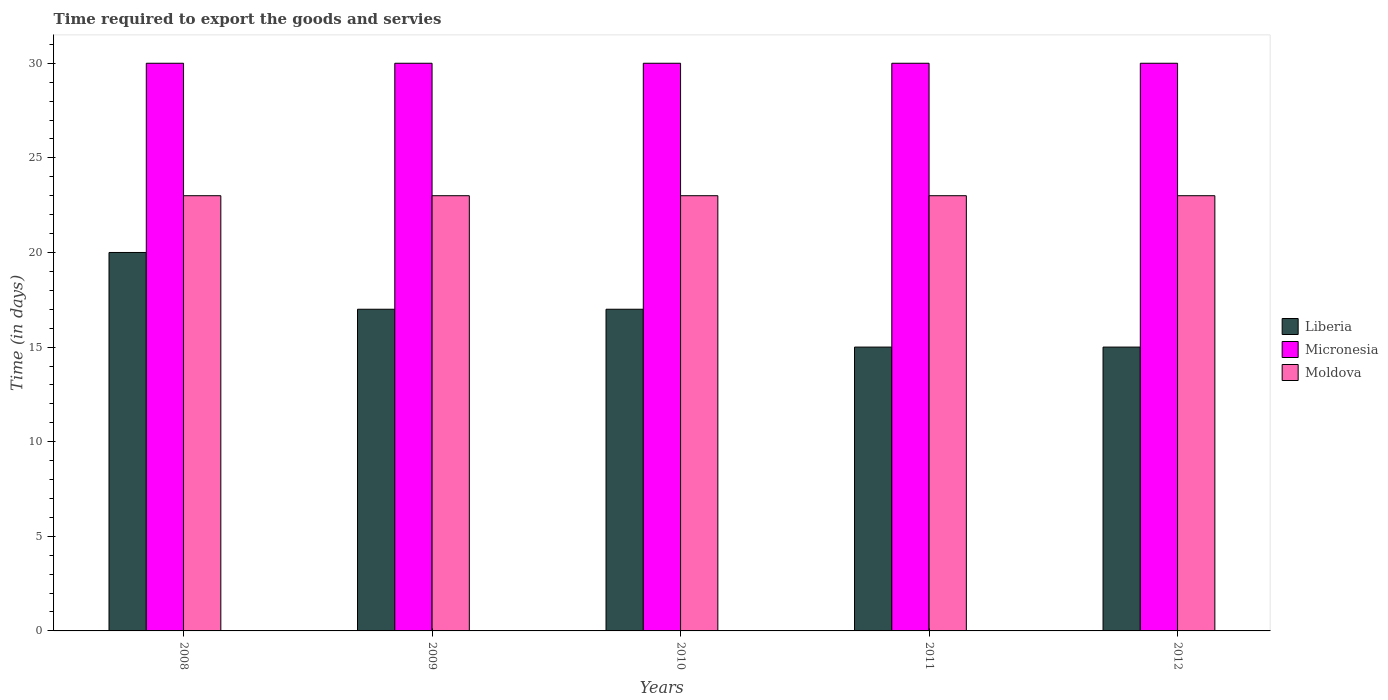How many different coloured bars are there?
Give a very brief answer. 3. Are the number of bars per tick equal to the number of legend labels?
Provide a succinct answer. Yes. Are the number of bars on each tick of the X-axis equal?
Offer a terse response. Yes. In how many cases, is the number of bars for a given year not equal to the number of legend labels?
Make the answer very short. 0. What is the number of days required to export the goods and services in Moldova in 2010?
Ensure brevity in your answer.  23. Across all years, what is the maximum number of days required to export the goods and services in Liberia?
Make the answer very short. 20. Across all years, what is the minimum number of days required to export the goods and services in Moldova?
Make the answer very short. 23. In which year was the number of days required to export the goods and services in Liberia minimum?
Ensure brevity in your answer.  2011. What is the total number of days required to export the goods and services in Moldova in the graph?
Give a very brief answer. 115. What is the difference between the number of days required to export the goods and services in Moldova in 2010 and the number of days required to export the goods and services in Micronesia in 2009?
Keep it short and to the point. -7. In the year 2011, what is the difference between the number of days required to export the goods and services in Micronesia and number of days required to export the goods and services in Moldova?
Make the answer very short. 7. What is the ratio of the number of days required to export the goods and services in Moldova in 2008 to that in 2010?
Provide a succinct answer. 1. What is the difference between the highest and the second highest number of days required to export the goods and services in Moldova?
Ensure brevity in your answer.  0. What is the difference between the highest and the lowest number of days required to export the goods and services in Micronesia?
Provide a short and direct response. 0. What does the 3rd bar from the left in 2008 represents?
Your answer should be compact. Moldova. What does the 1st bar from the right in 2011 represents?
Keep it short and to the point. Moldova. How many years are there in the graph?
Make the answer very short. 5. What is the difference between two consecutive major ticks on the Y-axis?
Offer a terse response. 5. Are the values on the major ticks of Y-axis written in scientific E-notation?
Your response must be concise. No. Does the graph contain grids?
Make the answer very short. No. Where does the legend appear in the graph?
Your answer should be very brief. Center right. How many legend labels are there?
Keep it short and to the point. 3. How are the legend labels stacked?
Provide a short and direct response. Vertical. What is the title of the graph?
Offer a very short reply. Time required to export the goods and servies. Does "Sri Lanka" appear as one of the legend labels in the graph?
Offer a terse response. No. What is the label or title of the Y-axis?
Your answer should be compact. Time (in days). What is the Time (in days) in Moldova in 2008?
Provide a succinct answer. 23. What is the Time (in days) in Liberia in 2009?
Offer a terse response. 17. What is the Time (in days) of Micronesia in 2009?
Offer a very short reply. 30. What is the Time (in days) in Liberia in 2010?
Your answer should be compact. 17. What is the Time (in days) of Moldova in 2010?
Keep it short and to the point. 23. What is the Time (in days) in Liberia in 2011?
Keep it short and to the point. 15. What is the Time (in days) in Moldova in 2011?
Offer a very short reply. 23. What is the Time (in days) in Liberia in 2012?
Give a very brief answer. 15. What is the Time (in days) in Moldova in 2012?
Provide a short and direct response. 23. Across all years, what is the maximum Time (in days) in Liberia?
Make the answer very short. 20. Across all years, what is the maximum Time (in days) of Moldova?
Offer a very short reply. 23. Across all years, what is the minimum Time (in days) in Liberia?
Your answer should be compact. 15. Across all years, what is the minimum Time (in days) of Moldova?
Give a very brief answer. 23. What is the total Time (in days) in Micronesia in the graph?
Your response must be concise. 150. What is the total Time (in days) of Moldova in the graph?
Make the answer very short. 115. What is the difference between the Time (in days) of Liberia in 2008 and that in 2009?
Ensure brevity in your answer.  3. What is the difference between the Time (in days) in Moldova in 2008 and that in 2009?
Ensure brevity in your answer.  0. What is the difference between the Time (in days) of Liberia in 2008 and that in 2010?
Your response must be concise. 3. What is the difference between the Time (in days) of Moldova in 2008 and that in 2010?
Your answer should be compact. 0. What is the difference between the Time (in days) in Micronesia in 2008 and that in 2011?
Provide a succinct answer. 0. What is the difference between the Time (in days) in Liberia in 2008 and that in 2012?
Offer a very short reply. 5. What is the difference between the Time (in days) of Moldova in 2008 and that in 2012?
Provide a succinct answer. 0. What is the difference between the Time (in days) in Liberia in 2009 and that in 2010?
Offer a very short reply. 0. What is the difference between the Time (in days) in Moldova in 2009 and that in 2010?
Provide a succinct answer. 0. What is the difference between the Time (in days) of Liberia in 2009 and that in 2011?
Offer a terse response. 2. What is the difference between the Time (in days) in Micronesia in 2009 and that in 2011?
Offer a very short reply. 0. What is the difference between the Time (in days) of Moldova in 2009 and that in 2011?
Ensure brevity in your answer.  0. What is the difference between the Time (in days) in Liberia in 2009 and that in 2012?
Offer a very short reply. 2. What is the difference between the Time (in days) of Micronesia in 2009 and that in 2012?
Your answer should be compact. 0. What is the difference between the Time (in days) of Moldova in 2009 and that in 2012?
Provide a short and direct response. 0. What is the difference between the Time (in days) in Micronesia in 2010 and that in 2011?
Make the answer very short. 0. What is the difference between the Time (in days) of Moldova in 2010 and that in 2011?
Your answer should be very brief. 0. What is the difference between the Time (in days) in Liberia in 2011 and that in 2012?
Make the answer very short. 0. What is the difference between the Time (in days) of Liberia in 2008 and the Time (in days) of Micronesia in 2010?
Provide a succinct answer. -10. What is the difference between the Time (in days) of Micronesia in 2008 and the Time (in days) of Moldova in 2010?
Ensure brevity in your answer.  7. What is the difference between the Time (in days) of Liberia in 2008 and the Time (in days) of Micronesia in 2011?
Give a very brief answer. -10. What is the difference between the Time (in days) in Liberia in 2008 and the Time (in days) in Moldova in 2011?
Offer a terse response. -3. What is the difference between the Time (in days) in Liberia in 2008 and the Time (in days) in Micronesia in 2012?
Offer a very short reply. -10. What is the difference between the Time (in days) in Liberia in 2008 and the Time (in days) in Moldova in 2012?
Your answer should be compact. -3. What is the difference between the Time (in days) of Liberia in 2009 and the Time (in days) of Micronesia in 2010?
Give a very brief answer. -13. What is the difference between the Time (in days) of Liberia in 2009 and the Time (in days) of Moldova in 2010?
Give a very brief answer. -6. What is the difference between the Time (in days) of Micronesia in 2009 and the Time (in days) of Moldova in 2010?
Your response must be concise. 7. What is the difference between the Time (in days) in Liberia in 2009 and the Time (in days) in Micronesia in 2011?
Your answer should be compact. -13. What is the difference between the Time (in days) of Liberia in 2009 and the Time (in days) of Moldova in 2012?
Provide a short and direct response. -6. What is the difference between the Time (in days) of Liberia in 2010 and the Time (in days) of Moldova in 2011?
Offer a terse response. -6. What is the difference between the Time (in days) of Micronesia in 2010 and the Time (in days) of Moldova in 2011?
Your answer should be compact. 7. What is the difference between the Time (in days) in Liberia in 2010 and the Time (in days) in Moldova in 2012?
Provide a succinct answer. -6. What is the difference between the Time (in days) of Micronesia in 2010 and the Time (in days) of Moldova in 2012?
Your answer should be compact. 7. What is the difference between the Time (in days) of Liberia in 2011 and the Time (in days) of Micronesia in 2012?
Keep it short and to the point. -15. What is the difference between the Time (in days) in Liberia in 2011 and the Time (in days) in Moldova in 2012?
Ensure brevity in your answer.  -8. What is the difference between the Time (in days) in Micronesia in 2011 and the Time (in days) in Moldova in 2012?
Your response must be concise. 7. What is the average Time (in days) of Liberia per year?
Keep it short and to the point. 16.8. What is the average Time (in days) in Micronesia per year?
Give a very brief answer. 30. In the year 2008, what is the difference between the Time (in days) in Liberia and Time (in days) in Micronesia?
Provide a succinct answer. -10. In the year 2008, what is the difference between the Time (in days) of Liberia and Time (in days) of Moldova?
Ensure brevity in your answer.  -3. In the year 2008, what is the difference between the Time (in days) of Micronesia and Time (in days) of Moldova?
Give a very brief answer. 7. In the year 2009, what is the difference between the Time (in days) in Liberia and Time (in days) in Moldova?
Provide a succinct answer. -6. In the year 2010, what is the difference between the Time (in days) in Liberia and Time (in days) in Micronesia?
Make the answer very short. -13. In the year 2010, what is the difference between the Time (in days) of Liberia and Time (in days) of Moldova?
Your answer should be compact. -6. In the year 2010, what is the difference between the Time (in days) in Micronesia and Time (in days) in Moldova?
Your answer should be compact. 7. In the year 2011, what is the difference between the Time (in days) in Liberia and Time (in days) in Moldova?
Keep it short and to the point. -8. In the year 2011, what is the difference between the Time (in days) in Micronesia and Time (in days) in Moldova?
Provide a short and direct response. 7. In the year 2012, what is the difference between the Time (in days) of Liberia and Time (in days) of Micronesia?
Offer a terse response. -15. What is the ratio of the Time (in days) of Liberia in 2008 to that in 2009?
Provide a short and direct response. 1.18. What is the ratio of the Time (in days) of Liberia in 2008 to that in 2010?
Offer a very short reply. 1.18. What is the ratio of the Time (in days) of Micronesia in 2008 to that in 2010?
Your answer should be compact. 1. What is the ratio of the Time (in days) of Moldova in 2008 to that in 2010?
Your answer should be very brief. 1. What is the ratio of the Time (in days) of Liberia in 2008 to that in 2011?
Your response must be concise. 1.33. What is the ratio of the Time (in days) of Liberia in 2008 to that in 2012?
Provide a succinct answer. 1.33. What is the ratio of the Time (in days) of Micronesia in 2008 to that in 2012?
Your answer should be compact. 1. What is the ratio of the Time (in days) in Micronesia in 2009 to that in 2010?
Your answer should be very brief. 1. What is the ratio of the Time (in days) in Moldova in 2009 to that in 2010?
Keep it short and to the point. 1. What is the ratio of the Time (in days) of Liberia in 2009 to that in 2011?
Provide a succinct answer. 1.13. What is the ratio of the Time (in days) of Micronesia in 2009 to that in 2011?
Offer a terse response. 1. What is the ratio of the Time (in days) in Moldova in 2009 to that in 2011?
Offer a very short reply. 1. What is the ratio of the Time (in days) in Liberia in 2009 to that in 2012?
Keep it short and to the point. 1.13. What is the ratio of the Time (in days) in Liberia in 2010 to that in 2011?
Provide a succinct answer. 1.13. What is the ratio of the Time (in days) of Micronesia in 2010 to that in 2011?
Your answer should be compact. 1. What is the ratio of the Time (in days) in Liberia in 2010 to that in 2012?
Provide a succinct answer. 1.13. What is the ratio of the Time (in days) of Moldova in 2011 to that in 2012?
Provide a succinct answer. 1. What is the difference between the highest and the second highest Time (in days) of Micronesia?
Your answer should be very brief. 0. What is the difference between the highest and the lowest Time (in days) of Liberia?
Keep it short and to the point. 5. What is the difference between the highest and the lowest Time (in days) in Micronesia?
Your response must be concise. 0. 